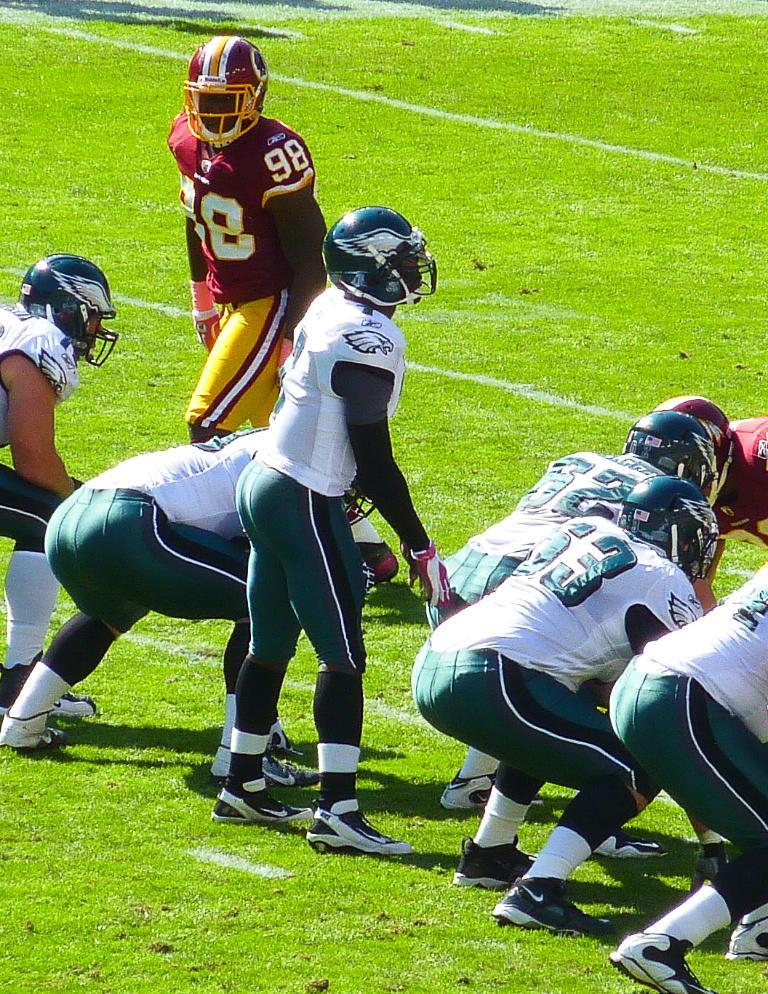What are the people in the image doing? The people in the image are playing. Where are the players located? The players are playing on a playground. What type of exchange is taking place between the players in the image? There is no exchange taking place between the players in the image; they are simply playing. What season is depicted in the image? The provided facts do not mention the season or weather, so it cannot be determined from the image. 